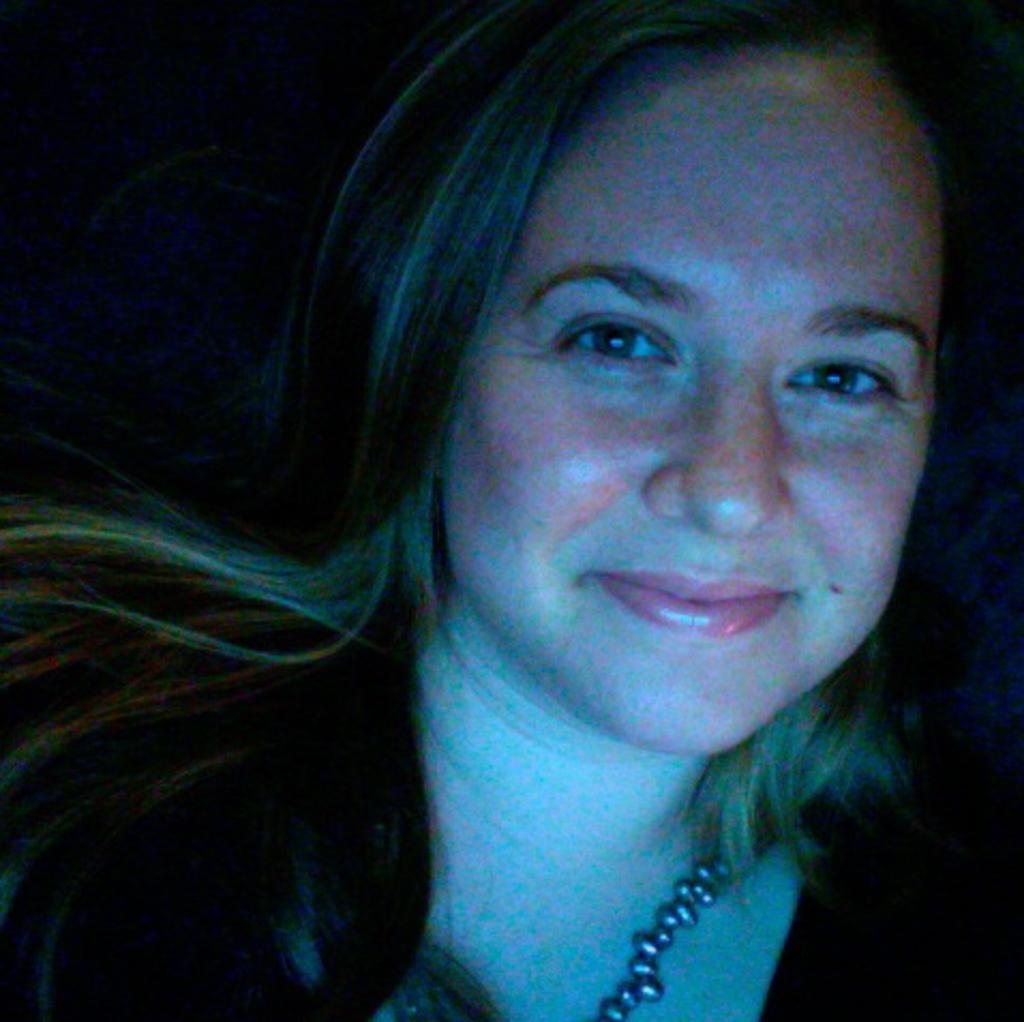Could you give a brief overview of what you see in this image? Here we can see a woman and she is smiling. 